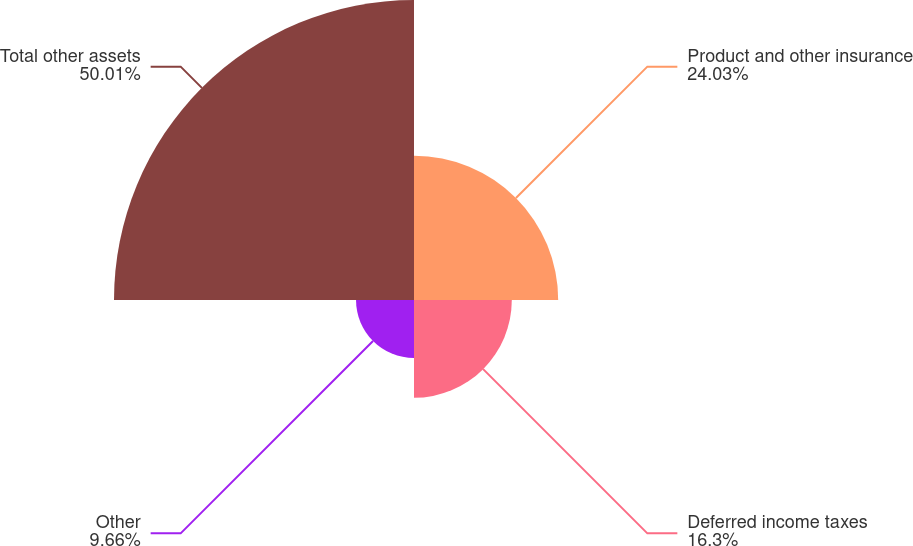Convert chart. <chart><loc_0><loc_0><loc_500><loc_500><pie_chart><fcel>Product and other insurance<fcel>Deferred income taxes<fcel>Other<fcel>Total other assets<nl><fcel>24.03%<fcel>16.3%<fcel>9.66%<fcel>50.0%<nl></chart> 